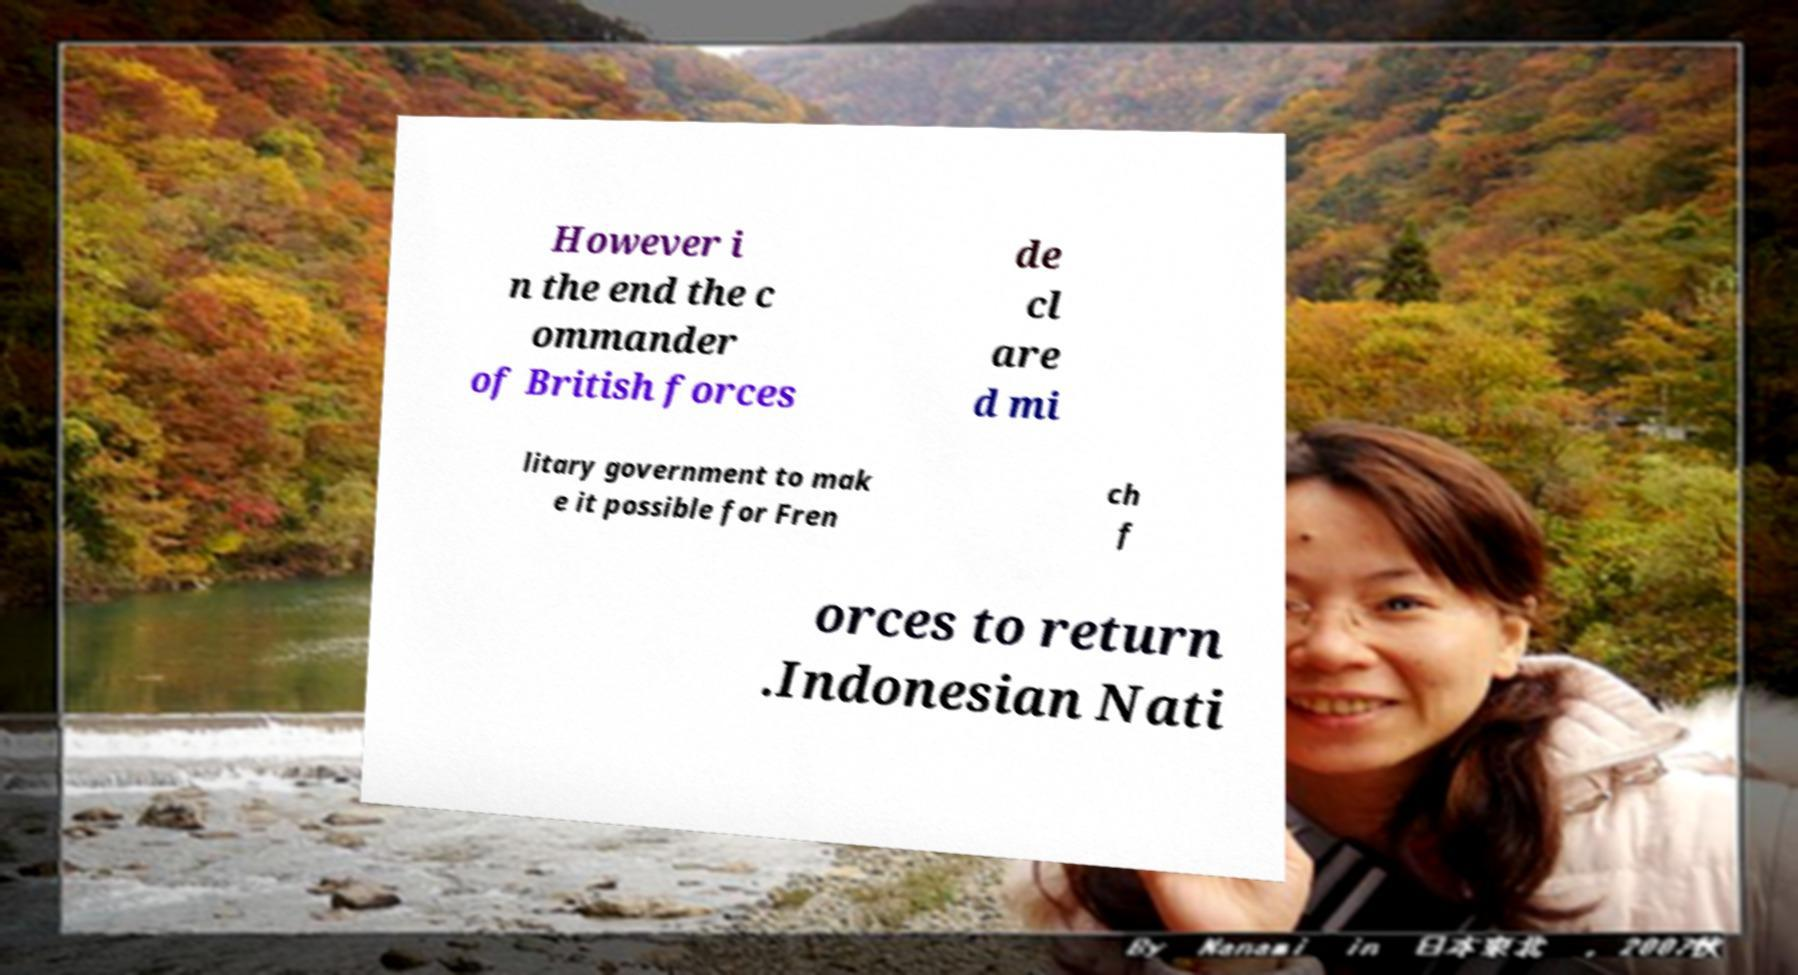For documentation purposes, I need the text within this image transcribed. Could you provide that? However i n the end the c ommander of British forces de cl are d mi litary government to mak e it possible for Fren ch f orces to return .Indonesian Nati 